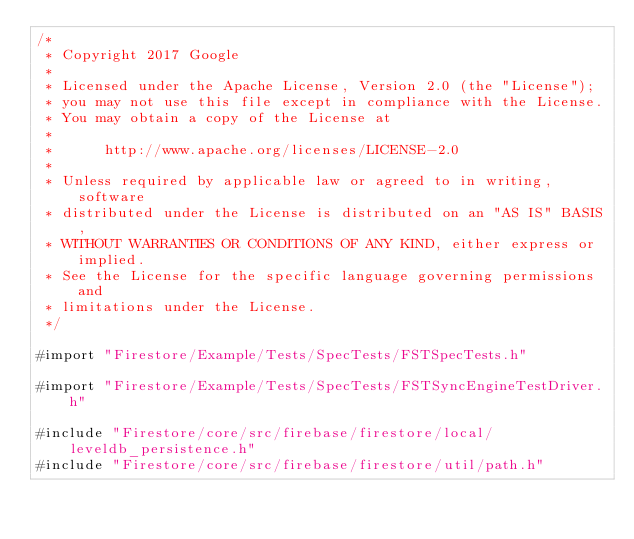<code> <loc_0><loc_0><loc_500><loc_500><_ObjectiveC_>/*
 * Copyright 2017 Google
 *
 * Licensed under the Apache License, Version 2.0 (the "License");
 * you may not use this file except in compliance with the License.
 * You may obtain a copy of the License at
 *
 *      http://www.apache.org/licenses/LICENSE-2.0
 *
 * Unless required by applicable law or agreed to in writing, software
 * distributed under the License is distributed on an "AS IS" BASIS,
 * WITHOUT WARRANTIES OR CONDITIONS OF ANY KIND, either express or implied.
 * See the License for the specific language governing permissions and
 * limitations under the License.
 */

#import "Firestore/Example/Tests/SpecTests/FSTSpecTests.h"

#import "Firestore/Example/Tests/SpecTests/FSTSyncEngineTestDriver.h"

#include "Firestore/core/src/firebase/firestore/local/leveldb_persistence.h"
#include "Firestore/core/src/firebase/firestore/util/path.h"</code> 